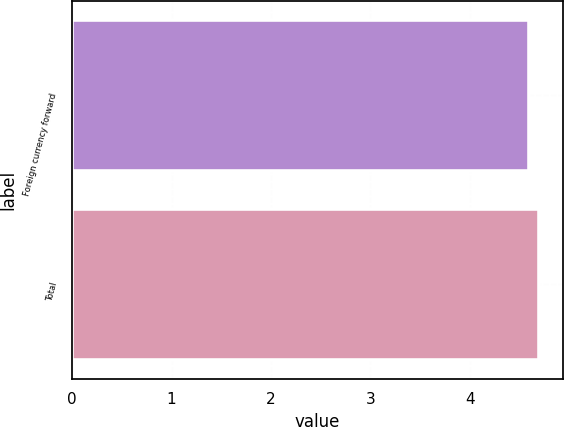Convert chart to OTSL. <chart><loc_0><loc_0><loc_500><loc_500><bar_chart><fcel>Foreign currency forward<fcel>Total<nl><fcel>4.6<fcel>4.7<nl></chart> 